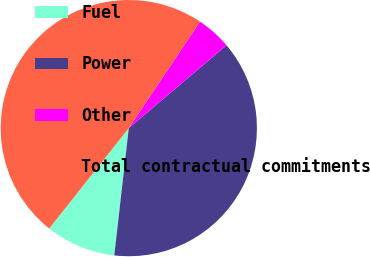Convert chart to OTSL. <chart><loc_0><loc_0><loc_500><loc_500><pie_chart><fcel>Fuel<fcel>Power<fcel>Other<fcel>Total contractual commitments<nl><fcel>8.86%<fcel>37.99%<fcel>4.43%<fcel>48.71%<nl></chart> 